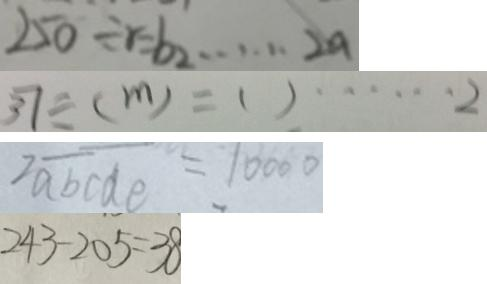Convert formula to latex. <formula><loc_0><loc_0><loc_500><loc_500>2 5 0 \div r = b _ { 2 } \cdots 2 a 
 3 7 \div ( m ) = ( ) \cdots 2 
 2 \overline { a b } \overline { c d e } = 1 0 0 0 0 
 2 4 3 - 2 0 5 = 3 8</formula> 